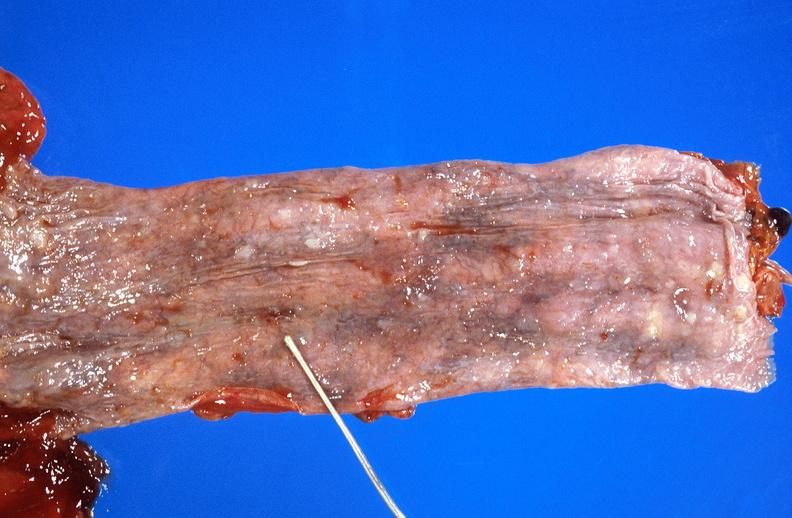does bicornate uterus show esophageal varices due to alcoholic cirrhosis?
Answer the question using a single word or phrase. No 